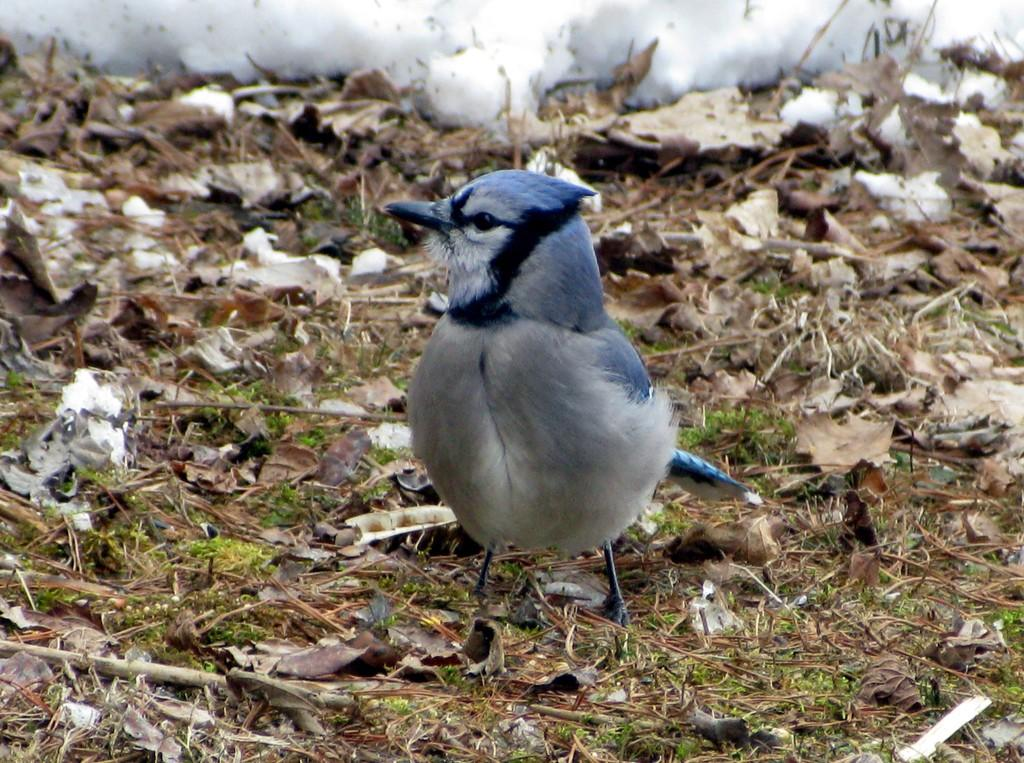What type of animal is in the picture? There is a small bird in the picture. Can you describe the bird's appearance? The bird has grey and white coloring. Where is the bird located in the image? The bird is sitting on the ground. What else can be seen on the ground in the image? There are dry leaves on the ground in the image. What type of lamp is illuminating the bird in the image? There is no lamp present in the image; the bird is sitting on the ground with dry leaves. How does the deer interact with the bird in the image? There is no deer present in the image; only the small bird and dry leaves are visible. 